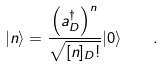<formula> <loc_0><loc_0><loc_500><loc_500>| n \rangle = \frac { \left ( a _ { D } ^ { \dagger } \right ) ^ { n } } { \sqrt { [ n ] _ { D } ! } } | 0 \rangle \quad .</formula> 